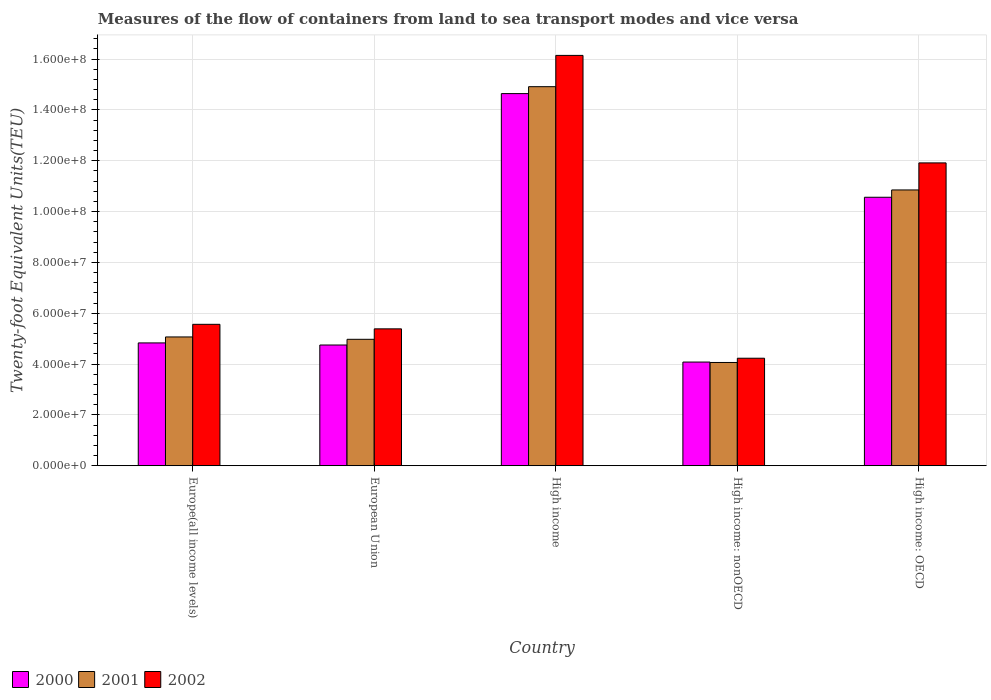How many different coloured bars are there?
Offer a very short reply. 3. How many groups of bars are there?
Ensure brevity in your answer.  5. Are the number of bars on each tick of the X-axis equal?
Keep it short and to the point. Yes. How many bars are there on the 3rd tick from the right?
Give a very brief answer. 3. What is the label of the 1st group of bars from the left?
Provide a short and direct response. Europe(all income levels). In how many cases, is the number of bars for a given country not equal to the number of legend labels?
Give a very brief answer. 0. What is the container port traffic in 2000 in High income: OECD?
Offer a very short reply. 1.06e+08. Across all countries, what is the maximum container port traffic in 2000?
Make the answer very short. 1.46e+08. Across all countries, what is the minimum container port traffic in 2000?
Ensure brevity in your answer.  4.08e+07. In which country was the container port traffic in 2000 maximum?
Keep it short and to the point. High income. In which country was the container port traffic in 2000 minimum?
Your answer should be compact. High income: nonOECD. What is the total container port traffic in 2002 in the graph?
Keep it short and to the point. 4.32e+08. What is the difference between the container port traffic in 2002 in High income and that in High income: nonOECD?
Make the answer very short. 1.19e+08. What is the difference between the container port traffic in 2002 in High income: OECD and the container port traffic in 2001 in European Union?
Ensure brevity in your answer.  6.94e+07. What is the average container port traffic in 2002 per country?
Make the answer very short. 8.65e+07. What is the difference between the container port traffic of/in 2001 and container port traffic of/in 2002 in High income?
Your answer should be very brief. -1.23e+07. In how many countries, is the container port traffic in 2002 greater than 4000000 TEU?
Offer a terse response. 5. What is the ratio of the container port traffic in 2002 in European Union to that in High income: nonOECD?
Offer a terse response. 1.27. Is the container port traffic in 2001 in European Union less than that in High income: OECD?
Provide a short and direct response. Yes. What is the difference between the highest and the second highest container port traffic in 2002?
Ensure brevity in your answer.  -1.06e+08. What is the difference between the highest and the lowest container port traffic in 2000?
Your response must be concise. 1.06e+08. What does the 1st bar from the left in Europe(all income levels) represents?
Provide a succinct answer. 2000. What does the 2nd bar from the right in European Union represents?
Make the answer very short. 2001. Is it the case that in every country, the sum of the container port traffic in 2001 and container port traffic in 2000 is greater than the container port traffic in 2002?
Your response must be concise. Yes. How many bars are there?
Provide a short and direct response. 15. How many countries are there in the graph?
Your response must be concise. 5. What is the difference between two consecutive major ticks on the Y-axis?
Offer a very short reply. 2.00e+07. Does the graph contain any zero values?
Give a very brief answer. No. Does the graph contain grids?
Your answer should be compact. Yes. Where does the legend appear in the graph?
Ensure brevity in your answer.  Bottom left. How are the legend labels stacked?
Keep it short and to the point. Horizontal. What is the title of the graph?
Offer a very short reply. Measures of the flow of containers from land to sea transport modes and vice versa. What is the label or title of the Y-axis?
Keep it short and to the point. Twenty-foot Equivalent Units(TEU). What is the Twenty-foot Equivalent Units(TEU) in 2000 in Europe(all income levels)?
Your response must be concise. 4.83e+07. What is the Twenty-foot Equivalent Units(TEU) in 2001 in Europe(all income levels)?
Give a very brief answer. 5.07e+07. What is the Twenty-foot Equivalent Units(TEU) of 2002 in Europe(all income levels)?
Keep it short and to the point. 5.56e+07. What is the Twenty-foot Equivalent Units(TEU) in 2000 in European Union?
Make the answer very short. 4.75e+07. What is the Twenty-foot Equivalent Units(TEU) in 2001 in European Union?
Keep it short and to the point. 4.97e+07. What is the Twenty-foot Equivalent Units(TEU) in 2002 in European Union?
Give a very brief answer. 5.38e+07. What is the Twenty-foot Equivalent Units(TEU) in 2000 in High income?
Offer a terse response. 1.46e+08. What is the Twenty-foot Equivalent Units(TEU) of 2001 in High income?
Keep it short and to the point. 1.49e+08. What is the Twenty-foot Equivalent Units(TEU) of 2002 in High income?
Keep it short and to the point. 1.61e+08. What is the Twenty-foot Equivalent Units(TEU) in 2000 in High income: nonOECD?
Give a very brief answer. 4.08e+07. What is the Twenty-foot Equivalent Units(TEU) in 2001 in High income: nonOECD?
Provide a short and direct response. 4.06e+07. What is the Twenty-foot Equivalent Units(TEU) in 2002 in High income: nonOECD?
Your answer should be very brief. 4.23e+07. What is the Twenty-foot Equivalent Units(TEU) in 2000 in High income: OECD?
Ensure brevity in your answer.  1.06e+08. What is the Twenty-foot Equivalent Units(TEU) of 2001 in High income: OECD?
Give a very brief answer. 1.08e+08. What is the Twenty-foot Equivalent Units(TEU) of 2002 in High income: OECD?
Provide a succinct answer. 1.19e+08. Across all countries, what is the maximum Twenty-foot Equivalent Units(TEU) of 2000?
Offer a very short reply. 1.46e+08. Across all countries, what is the maximum Twenty-foot Equivalent Units(TEU) in 2001?
Keep it short and to the point. 1.49e+08. Across all countries, what is the maximum Twenty-foot Equivalent Units(TEU) in 2002?
Provide a short and direct response. 1.61e+08. Across all countries, what is the minimum Twenty-foot Equivalent Units(TEU) in 2000?
Your answer should be compact. 4.08e+07. Across all countries, what is the minimum Twenty-foot Equivalent Units(TEU) in 2001?
Provide a short and direct response. 4.06e+07. Across all countries, what is the minimum Twenty-foot Equivalent Units(TEU) of 2002?
Offer a very short reply. 4.23e+07. What is the total Twenty-foot Equivalent Units(TEU) in 2000 in the graph?
Ensure brevity in your answer.  3.89e+08. What is the total Twenty-foot Equivalent Units(TEU) in 2001 in the graph?
Offer a terse response. 3.99e+08. What is the total Twenty-foot Equivalent Units(TEU) in 2002 in the graph?
Ensure brevity in your answer.  4.32e+08. What is the difference between the Twenty-foot Equivalent Units(TEU) of 2000 in Europe(all income levels) and that in European Union?
Provide a succinct answer. 8.26e+05. What is the difference between the Twenty-foot Equivalent Units(TEU) of 2001 in Europe(all income levels) and that in European Union?
Your answer should be compact. 9.30e+05. What is the difference between the Twenty-foot Equivalent Units(TEU) of 2002 in Europe(all income levels) and that in European Union?
Ensure brevity in your answer.  1.78e+06. What is the difference between the Twenty-foot Equivalent Units(TEU) of 2000 in Europe(all income levels) and that in High income?
Offer a terse response. -9.81e+07. What is the difference between the Twenty-foot Equivalent Units(TEU) in 2001 in Europe(all income levels) and that in High income?
Offer a terse response. -9.85e+07. What is the difference between the Twenty-foot Equivalent Units(TEU) of 2002 in Europe(all income levels) and that in High income?
Offer a very short reply. -1.06e+08. What is the difference between the Twenty-foot Equivalent Units(TEU) in 2000 in Europe(all income levels) and that in High income: nonOECD?
Keep it short and to the point. 7.53e+06. What is the difference between the Twenty-foot Equivalent Units(TEU) of 2001 in Europe(all income levels) and that in High income: nonOECD?
Your answer should be compact. 1.00e+07. What is the difference between the Twenty-foot Equivalent Units(TEU) of 2002 in Europe(all income levels) and that in High income: nonOECD?
Keep it short and to the point. 1.33e+07. What is the difference between the Twenty-foot Equivalent Units(TEU) in 2000 in Europe(all income levels) and that in High income: OECD?
Provide a succinct answer. -5.73e+07. What is the difference between the Twenty-foot Equivalent Units(TEU) in 2001 in Europe(all income levels) and that in High income: OECD?
Provide a succinct answer. -5.78e+07. What is the difference between the Twenty-foot Equivalent Units(TEU) of 2002 in Europe(all income levels) and that in High income: OECD?
Ensure brevity in your answer.  -6.35e+07. What is the difference between the Twenty-foot Equivalent Units(TEU) in 2000 in European Union and that in High income?
Give a very brief answer. -9.89e+07. What is the difference between the Twenty-foot Equivalent Units(TEU) of 2001 in European Union and that in High income?
Your answer should be compact. -9.94e+07. What is the difference between the Twenty-foot Equivalent Units(TEU) of 2002 in European Union and that in High income?
Keep it short and to the point. -1.08e+08. What is the difference between the Twenty-foot Equivalent Units(TEU) of 2000 in European Union and that in High income: nonOECD?
Give a very brief answer. 6.71e+06. What is the difference between the Twenty-foot Equivalent Units(TEU) in 2001 in European Union and that in High income: nonOECD?
Ensure brevity in your answer.  9.11e+06. What is the difference between the Twenty-foot Equivalent Units(TEU) in 2002 in European Union and that in High income: nonOECD?
Ensure brevity in your answer.  1.16e+07. What is the difference between the Twenty-foot Equivalent Units(TEU) in 2000 in European Union and that in High income: OECD?
Your response must be concise. -5.81e+07. What is the difference between the Twenty-foot Equivalent Units(TEU) in 2001 in European Union and that in High income: OECD?
Give a very brief answer. -5.88e+07. What is the difference between the Twenty-foot Equivalent Units(TEU) in 2002 in European Union and that in High income: OECD?
Offer a terse response. -6.53e+07. What is the difference between the Twenty-foot Equivalent Units(TEU) of 2000 in High income and that in High income: nonOECD?
Your response must be concise. 1.06e+08. What is the difference between the Twenty-foot Equivalent Units(TEU) of 2001 in High income and that in High income: nonOECD?
Provide a succinct answer. 1.08e+08. What is the difference between the Twenty-foot Equivalent Units(TEU) in 2002 in High income and that in High income: nonOECD?
Provide a succinct answer. 1.19e+08. What is the difference between the Twenty-foot Equivalent Units(TEU) of 2000 in High income and that in High income: OECD?
Provide a succinct answer. 4.08e+07. What is the difference between the Twenty-foot Equivalent Units(TEU) in 2001 in High income and that in High income: OECD?
Your answer should be very brief. 4.06e+07. What is the difference between the Twenty-foot Equivalent Units(TEU) of 2002 in High income and that in High income: OECD?
Give a very brief answer. 4.23e+07. What is the difference between the Twenty-foot Equivalent Units(TEU) of 2000 in High income: nonOECD and that in High income: OECD?
Your answer should be very brief. -6.48e+07. What is the difference between the Twenty-foot Equivalent Units(TEU) of 2001 in High income: nonOECD and that in High income: OECD?
Ensure brevity in your answer.  -6.79e+07. What is the difference between the Twenty-foot Equivalent Units(TEU) in 2002 in High income: nonOECD and that in High income: OECD?
Your response must be concise. -7.68e+07. What is the difference between the Twenty-foot Equivalent Units(TEU) of 2000 in Europe(all income levels) and the Twenty-foot Equivalent Units(TEU) of 2001 in European Union?
Provide a succinct answer. -1.42e+06. What is the difference between the Twenty-foot Equivalent Units(TEU) of 2000 in Europe(all income levels) and the Twenty-foot Equivalent Units(TEU) of 2002 in European Union?
Your answer should be very brief. -5.53e+06. What is the difference between the Twenty-foot Equivalent Units(TEU) of 2001 in Europe(all income levels) and the Twenty-foot Equivalent Units(TEU) of 2002 in European Union?
Give a very brief answer. -3.19e+06. What is the difference between the Twenty-foot Equivalent Units(TEU) in 2000 in Europe(all income levels) and the Twenty-foot Equivalent Units(TEU) in 2001 in High income?
Ensure brevity in your answer.  -1.01e+08. What is the difference between the Twenty-foot Equivalent Units(TEU) of 2000 in Europe(all income levels) and the Twenty-foot Equivalent Units(TEU) of 2002 in High income?
Keep it short and to the point. -1.13e+08. What is the difference between the Twenty-foot Equivalent Units(TEU) of 2001 in Europe(all income levels) and the Twenty-foot Equivalent Units(TEU) of 2002 in High income?
Offer a very short reply. -1.11e+08. What is the difference between the Twenty-foot Equivalent Units(TEU) in 2000 in Europe(all income levels) and the Twenty-foot Equivalent Units(TEU) in 2001 in High income: nonOECD?
Make the answer very short. 7.69e+06. What is the difference between the Twenty-foot Equivalent Units(TEU) in 2000 in Europe(all income levels) and the Twenty-foot Equivalent Units(TEU) in 2002 in High income: nonOECD?
Offer a terse response. 6.02e+06. What is the difference between the Twenty-foot Equivalent Units(TEU) of 2001 in Europe(all income levels) and the Twenty-foot Equivalent Units(TEU) of 2002 in High income: nonOECD?
Provide a short and direct response. 8.37e+06. What is the difference between the Twenty-foot Equivalent Units(TEU) in 2000 in Europe(all income levels) and the Twenty-foot Equivalent Units(TEU) in 2001 in High income: OECD?
Keep it short and to the point. -6.02e+07. What is the difference between the Twenty-foot Equivalent Units(TEU) of 2000 in Europe(all income levels) and the Twenty-foot Equivalent Units(TEU) of 2002 in High income: OECD?
Keep it short and to the point. -7.08e+07. What is the difference between the Twenty-foot Equivalent Units(TEU) in 2001 in Europe(all income levels) and the Twenty-foot Equivalent Units(TEU) in 2002 in High income: OECD?
Ensure brevity in your answer.  -6.85e+07. What is the difference between the Twenty-foot Equivalent Units(TEU) of 2000 in European Union and the Twenty-foot Equivalent Units(TEU) of 2001 in High income?
Ensure brevity in your answer.  -1.02e+08. What is the difference between the Twenty-foot Equivalent Units(TEU) of 2000 in European Union and the Twenty-foot Equivalent Units(TEU) of 2002 in High income?
Offer a very short reply. -1.14e+08. What is the difference between the Twenty-foot Equivalent Units(TEU) in 2001 in European Union and the Twenty-foot Equivalent Units(TEU) in 2002 in High income?
Keep it short and to the point. -1.12e+08. What is the difference between the Twenty-foot Equivalent Units(TEU) in 2000 in European Union and the Twenty-foot Equivalent Units(TEU) in 2001 in High income: nonOECD?
Your answer should be very brief. 6.87e+06. What is the difference between the Twenty-foot Equivalent Units(TEU) of 2000 in European Union and the Twenty-foot Equivalent Units(TEU) of 2002 in High income: nonOECD?
Your response must be concise. 5.19e+06. What is the difference between the Twenty-foot Equivalent Units(TEU) of 2001 in European Union and the Twenty-foot Equivalent Units(TEU) of 2002 in High income: nonOECD?
Provide a succinct answer. 7.44e+06. What is the difference between the Twenty-foot Equivalent Units(TEU) of 2000 in European Union and the Twenty-foot Equivalent Units(TEU) of 2001 in High income: OECD?
Provide a short and direct response. -6.10e+07. What is the difference between the Twenty-foot Equivalent Units(TEU) of 2000 in European Union and the Twenty-foot Equivalent Units(TEU) of 2002 in High income: OECD?
Your answer should be very brief. -7.16e+07. What is the difference between the Twenty-foot Equivalent Units(TEU) in 2001 in European Union and the Twenty-foot Equivalent Units(TEU) in 2002 in High income: OECD?
Give a very brief answer. -6.94e+07. What is the difference between the Twenty-foot Equivalent Units(TEU) of 2000 in High income and the Twenty-foot Equivalent Units(TEU) of 2001 in High income: nonOECD?
Your answer should be very brief. 1.06e+08. What is the difference between the Twenty-foot Equivalent Units(TEU) in 2000 in High income and the Twenty-foot Equivalent Units(TEU) in 2002 in High income: nonOECD?
Provide a succinct answer. 1.04e+08. What is the difference between the Twenty-foot Equivalent Units(TEU) in 2001 in High income and the Twenty-foot Equivalent Units(TEU) in 2002 in High income: nonOECD?
Provide a succinct answer. 1.07e+08. What is the difference between the Twenty-foot Equivalent Units(TEU) of 2000 in High income and the Twenty-foot Equivalent Units(TEU) of 2001 in High income: OECD?
Keep it short and to the point. 3.79e+07. What is the difference between the Twenty-foot Equivalent Units(TEU) of 2000 in High income and the Twenty-foot Equivalent Units(TEU) of 2002 in High income: OECD?
Your response must be concise. 2.73e+07. What is the difference between the Twenty-foot Equivalent Units(TEU) in 2001 in High income and the Twenty-foot Equivalent Units(TEU) in 2002 in High income: OECD?
Give a very brief answer. 3.00e+07. What is the difference between the Twenty-foot Equivalent Units(TEU) of 2000 in High income: nonOECD and the Twenty-foot Equivalent Units(TEU) of 2001 in High income: OECD?
Make the answer very short. -6.77e+07. What is the difference between the Twenty-foot Equivalent Units(TEU) in 2000 in High income: nonOECD and the Twenty-foot Equivalent Units(TEU) in 2002 in High income: OECD?
Keep it short and to the point. -7.83e+07. What is the difference between the Twenty-foot Equivalent Units(TEU) of 2001 in High income: nonOECD and the Twenty-foot Equivalent Units(TEU) of 2002 in High income: OECD?
Your answer should be very brief. -7.85e+07. What is the average Twenty-foot Equivalent Units(TEU) in 2000 per country?
Ensure brevity in your answer.  7.77e+07. What is the average Twenty-foot Equivalent Units(TEU) of 2001 per country?
Your answer should be compact. 7.97e+07. What is the average Twenty-foot Equivalent Units(TEU) of 2002 per country?
Offer a very short reply. 8.65e+07. What is the difference between the Twenty-foot Equivalent Units(TEU) in 2000 and Twenty-foot Equivalent Units(TEU) in 2001 in Europe(all income levels)?
Keep it short and to the point. -2.35e+06. What is the difference between the Twenty-foot Equivalent Units(TEU) of 2000 and Twenty-foot Equivalent Units(TEU) of 2002 in Europe(all income levels)?
Keep it short and to the point. -7.32e+06. What is the difference between the Twenty-foot Equivalent Units(TEU) in 2001 and Twenty-foot Equivalent Units(TEU) in 2002 in Europe(all income levels)?
Provide a short and direct response. -4.97e+06. What is the difference between the Twenty-foot Equivalent Units(TEU) in 2000 and Twenty-foot Equivalent Units(TEU) in 2001 in European Union?
Make the answer very short. -2.24e+06. What is the difference between the Twenty-foot Equivalent Units(TEU) of 2000 and Twenty-foot Equivalent Units(TEU) of 2002 in European Union?
Make the answer very short. -6.36e+06. What is the difference between the Twenty-foot Equivalent Units(TEU) of 2001 and Twenty-foot Equivalent Units(TEU) of 2002 in European Union?
Ensure brevity in your answer.  -4.11e+06. What is the difference between the Twenty-foot Equivalent Units(TEU) in 2000 and Twenty-foot Equivalent Units(TEU) in 2001 in High income?
Your response must be concise. -2.72e+06. What is the difference between the Twenty-foot Equivalent Units(TEU) of 2000 and Twenty-foot Equivalent Units(TEU) of 2002 in High income?
Give a very brief answer. -1.50e+07. What is the difference between the Twenty-foot Equivalent Units(TEU) of 2001 and Twenty-foot Equivalent Units(TEU) of 2002 in High income?
Your response must be concise. -1.23e+07. What is the difference between the Twenty-foot Equivalent Units(TEU) of 2000 and Twenty-foot Equivalent Units(TEU) of 2001 in High income: nonOECD?
Ensure brevity in your answer.  1.60e+05. What is the difference between the Twenty-foot Equivalent Units(TEU) of 2000 and Twenty-foot Equivalent Units(TEU) of 2002 in High income: nonOECD?
Give a very brief answer. -1.51e+06. What is the difference between the Twenty-foot Equivalent Units(TEU) in 2001 and Twenty-foot Equivalent Units(TEU) in 2002 in High income: nonOECD?
Provide a short and direct response. -1.67e+06. What is the difference between the Twenty-foot Equivalent Units(TEU) of 2000 and Twenty-foot Equivalent Units(TEU) of 2001 in High income: OECD?
Provide a short and direct response. -2.88e+06. What is the difference between the Twenty-foot Equivalent Units(TEU) in 2000 and Twenty-foot Equivalent Units(TEU) in 2002 in High income: OECD?
Offer a very short reply. -1.35e+07. What is the difference between the Twenty-foot Equivalent Units(TEU) of 2001 and Twenty-foot Equivalent Units(TEU) of 2002 in High income: OECD?
Your response must be concise. -1.06e+07. What is the ratio of the Twenty-foot Equivalent Units(TEU) of 2000 in Europe(all income levels) to that in European Union?
Offer a terse response. 1.02. What is the ratio of the Twenty-foot Equivalent Units(TEU) of 2001 in Europe(all income levels) to that in European Union?
Ensure brevity in your answer.  1.02. What is the ratio of the Twenty-foot Equivalent Units(TEU) of 2002 in Europe(all income levels) to that in European Union?
Make the answer very short. 1.03. What is the ratio of the Twenty-foot Equivalent Units(TEU) of 2000 in Europe(all income levels) to that in High income?
Ensure brevity in your answer.  0.33. What is the ratio of the Twenty-foot Equivalent Units(TEU) in 2001 in Europe(all income levels) to that in High income?
Keep it short and to the point. 0.34. What is the ratio of the Twenty-foot Equivalent Units(TEU) in 2002 in Europe(all income levels) to that in High income?
Make the answer very short. 0.34. What is the ratio of the Twenty-foot Equivalent Units(TEU) of 2000 in Europe(all income levels) to that in High income: nonOECD?
Offer a very short reply. 1.18. What is the ratio of the Twenty-foot Equivalent Units(TEU) of 2001 in Europe(all income levels) to that in High income: nonOECD?
Offer a terse response. 1.25. What is the ratio of the Twenty-foot Equivalent Units(TEU) in 2002 in Europe(all income levels) to that in High income: nonOECD?
Your answer should be very brief. 1.32. What is the ratio of the Twenty-foot Equivalent Units(TEU) of 2000 in Europe(all income levels) to that in High income: OECD?
Offer a terse response. 0.46. What is the ratio of the Twenty-foot Equivalent Units(TEU) in 2001 in Europe(all income levels) to that in High income: OECD?
Offer a terse response. 0.47. What is the ratio of the Twenty-foot Equivalent Units(TEU) in 2002 in Europe(all income levels) to that in High income: OECD?
Your answer should be compact. 0.47. What is the ratio of the Twenty-foot Equivalent Units(TEU) of 2000 in European Union to that in High income?
Your answer should be very brief. 0.32. What is the ratio of the Twenty-foot Equivalent Units(TEU) of 2001 in European Union to that in High income?
Your answer should be compact. 0.33. What is the ratio of the Twenty-foot Equivalent Units(TEU) of 2002 in European Union to that in High income?
Offer a very short reply. 0.33. What is the ratio of the Twenty-foot Equivalent Units(TEU) in 2000 in European Union to that in High income: nonOECD?
Keep it short and to the point. 1.16. What is the ratio of the Twenty-foot Equivalent Units(TEU) of 2001 in European Union to that in High income: nonOECD?
Your response must be concise. 1.22. What is the ratio of the Twenty-foot Equivalent Units(TEU) in 2002 in European Union to that in High income: nonOECD?
Give a very brief answer. 1.27. What is the ratio of the Twenty-foot Equivalent Units(TEU) in 2000 in European Union to that in High income: OECD?
Your answer should be compact. 0.45. What is the ratio of the Twenty-foot Equivalent Units(TEU) in 2001 in European Union to that in High income: OECD?
Give a very brief answer. 0.46. What is the ratio of the Twenty-foot Equivalent Units(TEU) in 2002 in European Union to that in High income: OECD?
Offer a terse response. 0.45. What is the ratio of the Twenty-foot Equivalent Units(TEU) in 2000 in High income to that in High income: nonOECD?
Make the answer very short. 3.59. What is the ratio of the Twenty-foot Equivalent Units(TEU) in 2001 in High income to that in High income: nonOECD?
Ensure brevity in your answer.  3.67. What is the ratio of the Twenty-foot Equivalent Units(TEU) in 2002 in High income to that in High income: nonOECD?
Provide a succinct answer. 3.82. What is the ratio of the Twenty-foot Equivalent Units(TEU) in 2000 in High income to that in High income: OECD?
Ensure brevity in your answer.  1.39. What is the ratio of the Twenty-foot Equivalent Units(TEU) in 2001 in High income to that in High income: OECD?
Your answer should be very brief. 1.37. What is the ratio of the Twenty-foot Equivalent Units(TEU) of 2002 in High income to that in High income: OECD?
Your answer should be compact. 1.35. What is the ratio of the Twenty-foot Equivalent Units(TEU) of 2000 in High income: nonOECD to that in High income: OECD?
Ensure brevity in your answer.  0.39. What is the ratio of the Twenty-foot Equivalent Units(TEU) of 2001 in High income: nonOECD to that in High income: OECD?
Your answer should be very brief. 0.37. What is the ratio of the Twenty-foot Equivalent Units(TEU) of 2002 in High income: nonOECD to that in High income: OECD?
Your response must be concise. 0.35. What is the difference between the highest and the second highest Twenty-foot Equivalent Units(TEU) in 2000?
Offer a terse response. 4.08e+07. What is the difference between the highest and the second highest Twenty-foot Equivalent Units(TEU) in 2001?
Offer a terse response. 4.06e+07. What is the difference between the highest and the second highest Twenty-foot Equivalent Units(TEU) in 2002?
Your response must be concise. 4.23e+07. What is the difference between the highest and the lowest Twenty-foot Equivalent Units(TEU) of 2000?
Provide a short and direct response. 1.06e+08. What is the difference between the highest and the lowest Twenty-foot Equivalent Units(TEU) of 2001?
Give a very brief answer. 1.08e+08. What is the difference between the highest and the lowest Twenty-foot Equivalent Units(TEU) in 2002?
Provide a succinct answer. 1.19e+08. 